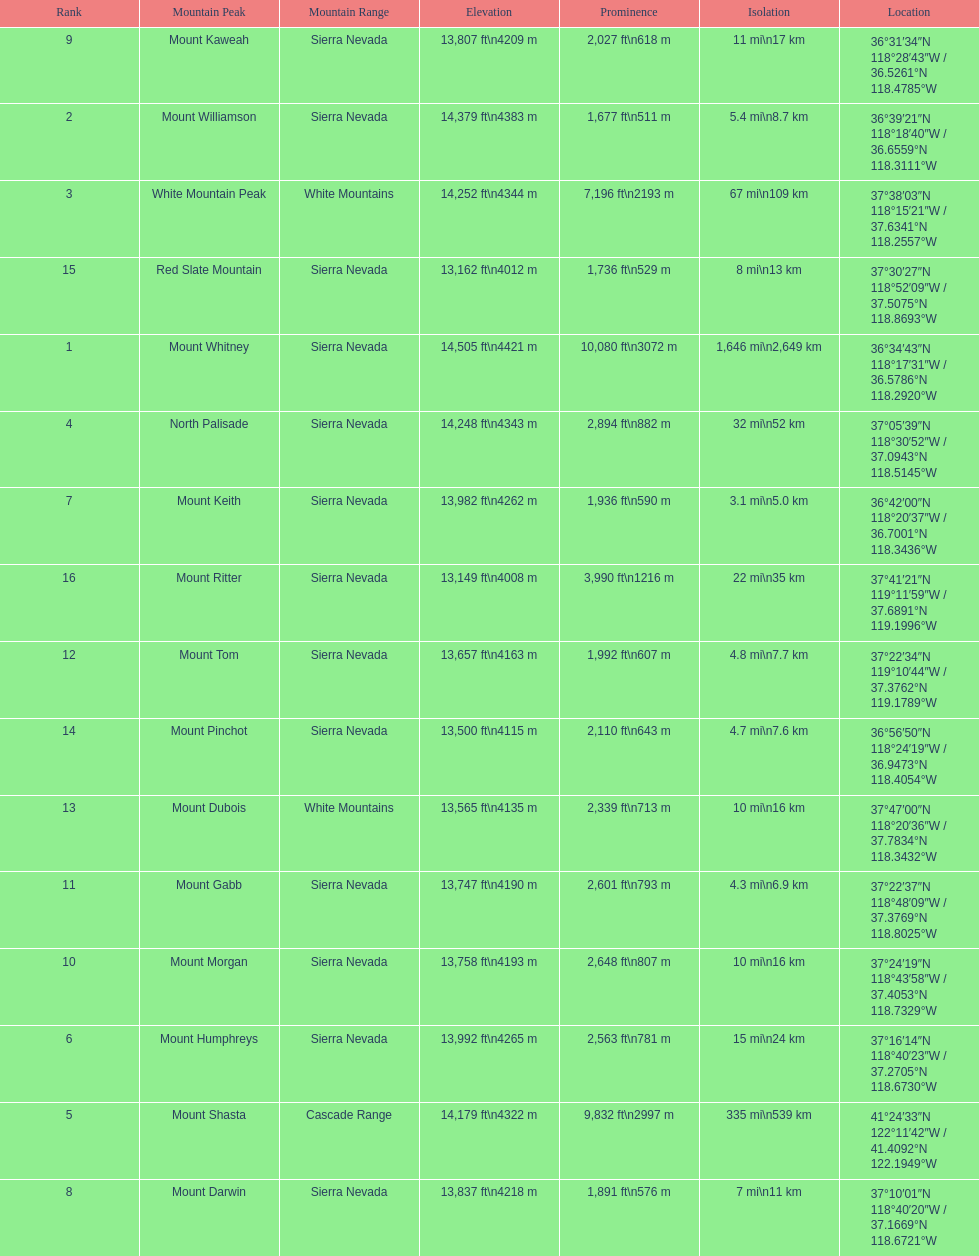How much taller is the mountain peak of mount williamson than that of mount keith? 397 ft. 